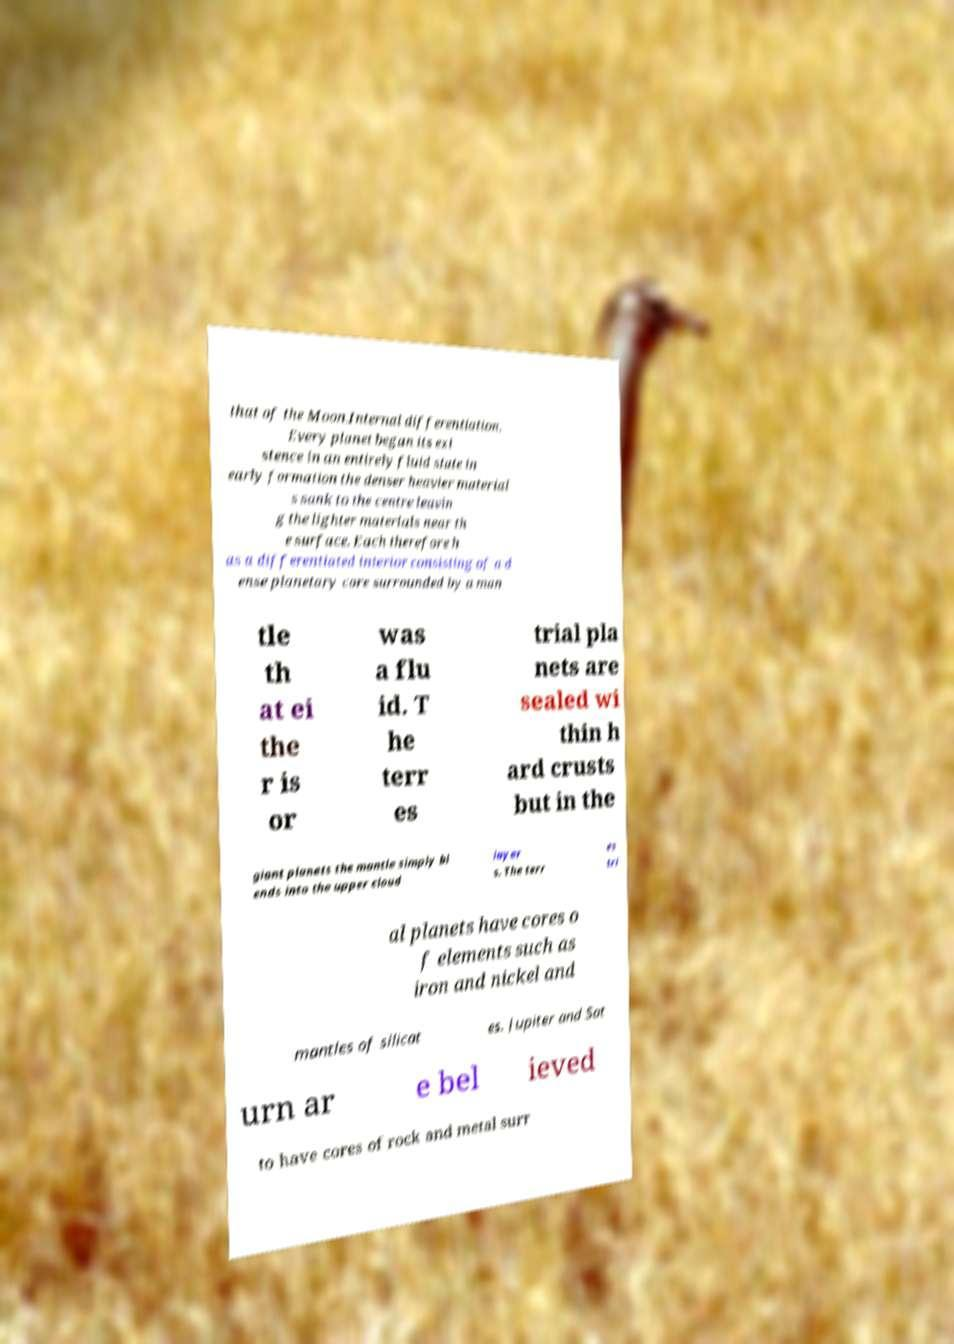There's text embedded in this image that I need extracted. Can you transcribe it verbatim? that of the Moon.Internal differentiation. Every planet began its exi stence in an entirely fluid state in early formation the denser heavier material s sank to the centre leavin g the lighter materials near th e surface. Each therefore h as a differentiated interior consisting of a d ense planetary core surrounded by a man tle th at ei the r is or was a flu id. T he terr es trial pla nets are sealed wi thin h ard crusts but in the giant planets the mantle simply bl ends into the upper cloud layer s. The terr es tri al planets have cores o f elements such as iron and nickel and mantles of silicat es. Jupiter and Sat urn ar e bel ieved to have cores of rock and metal surr 